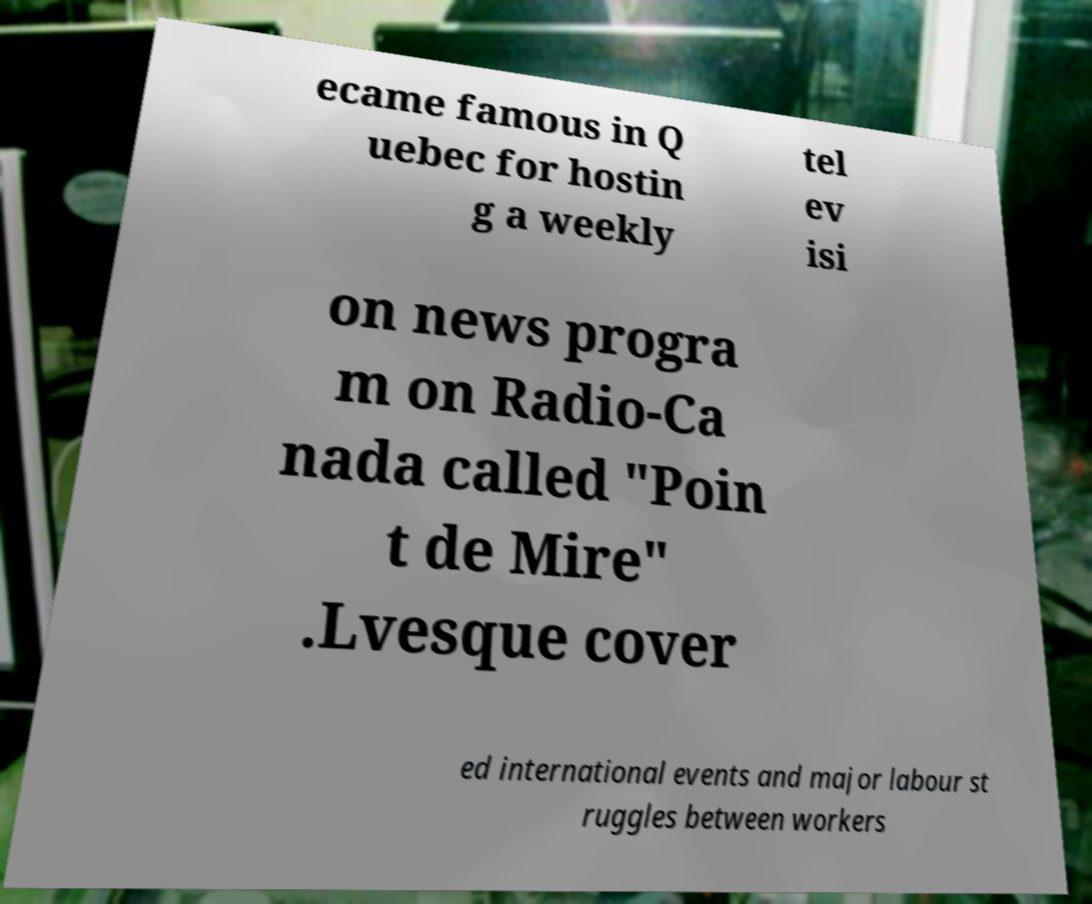Can you read and provide the text displayed in the image?This photo seems to have some interesting text. Can you extract and type it out for me? ecame famous in Q uebec for hostin g a weekly tel ev isi on news progra m on Radio-Ca nada called "Poin t de Mire" .Lvesque cover ed international events and major labour st ruggles between workers 